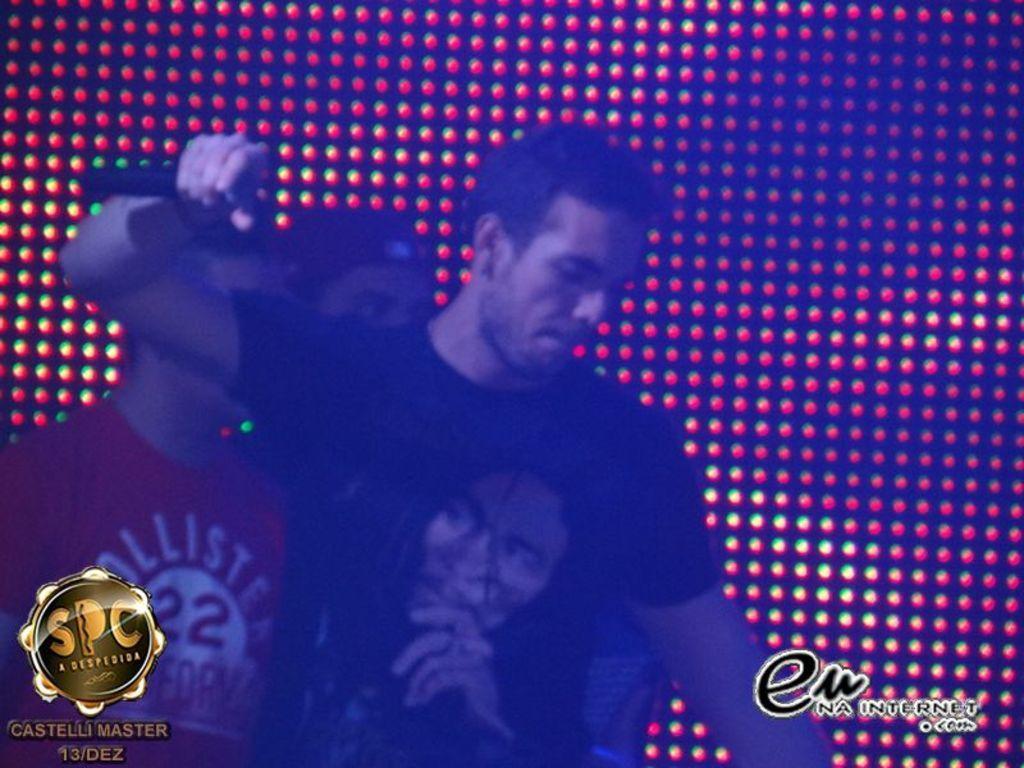Could you give a brief overview of what you see in this image? There are three persons standing and wearing a black color t shirts on the left side of this image. There is a wall with some lights in the background. There is a logo at the bottom left corner of this image and bottom right corner of this image as well. 